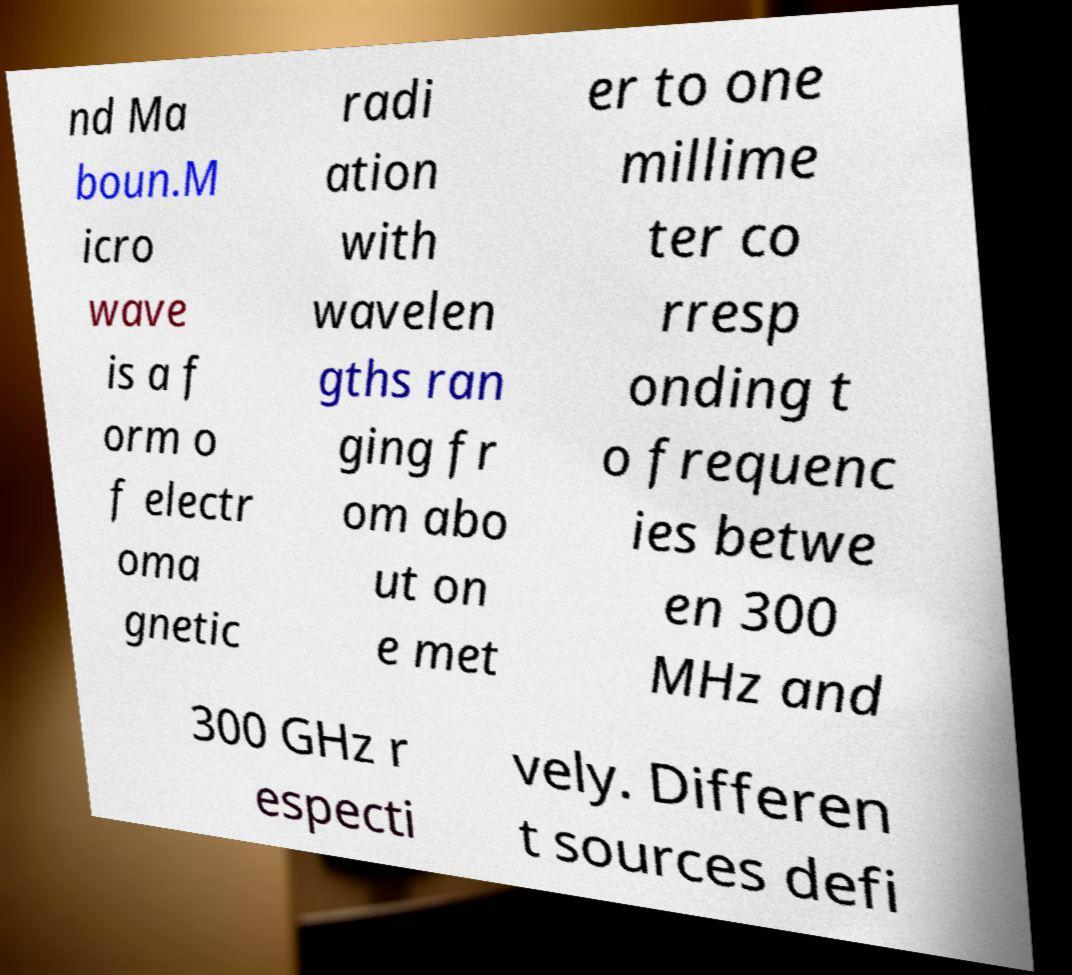I need the written content from this picture converted into text. Can you do that? nd Ma boun.M icro wave is a f orm o f electr oma gnetic radi ation with wavelen gths ran ging fr om abo ut on e met er to one millime ter co rresp onding t o frequenc ies betwe en 300 MHz and 300 GHz r especti vely. Differen t sources defi 